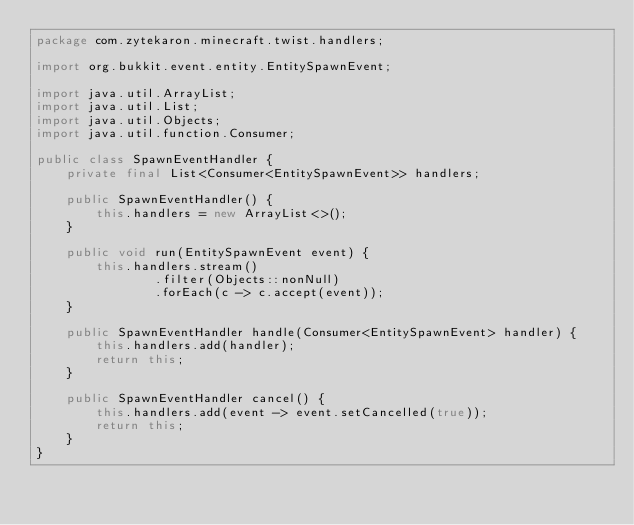Convert code to text. <code><loc_0><loc_0><loc_500><loc_500><_Java_>package com.zytekaron.minecraft.twist.handlers;

import org.bukkit.event.entity.EntitySpawnEvent;

import java.util.ArrayList;
import java.util.List;
import java.util.Objects;
import java.util.function.Consumer;

public class SpawnEventHandler {
    private final List<Consumer<EntitySpawnEvent>> handlers;
    
    public SpawnEventHandler() {
        this.handlers = new ArrayList<>();
    }
    
    public void run(EntitySpawnEvent event) {
        this.handlers.stream()
                .filter(Objects::nonNull)
                .forEach(c -> c.accept(event));
    }
    
    public SpawnEventHandler handle(Consumer<EntitySpawnEvent> handler) {
        this.handlers.add(handler);
        return this;
    }
    
    public SpawnEventHandler cancel() {
        this.handlers.add(event -> event.setCancelled(true));
        return this;
    }
}
</code> 